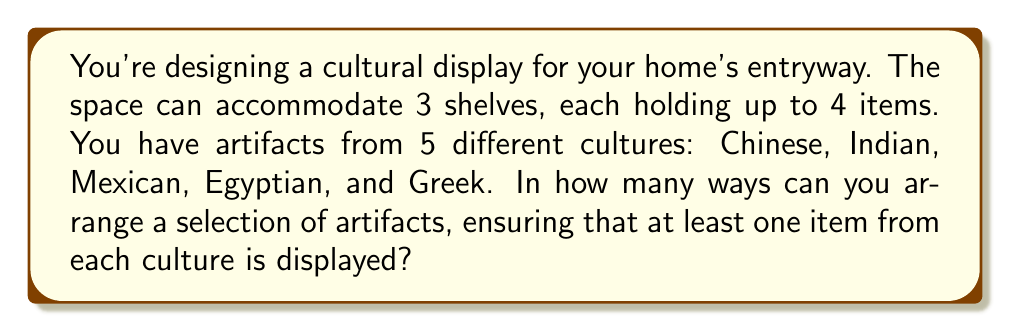Can you answer this question? Let's approach this step-by-step:

1) First, we need to ensure that at least one item from each culture is displayed. This means we must choose 5 items, one from each culture, to start with.

2) After placing these 5 items, we have $3 \times 4 - 5 = 7$ spaces left to fill.

3) For these remaining 7 spaces, we can choose any items from any culture. This is equivalent to choosing with replacement from 5 options (cultures) for 7 positions.

4) The number of ways to do this is $5^7$, as for each of the 7 positions, we have 5 choices.

5) However, we're not done yet. We need to consider the arrangement of all these items on the shelves.

6) The total number of items we're arranging is $5 + 7 = 12$.

7) This is a permutation problem. The number of ways to arrange 12 items is $12!$.

8) Therefore, the total number of possible arrangements is:

   $$ 5^7 \times 12! $$

9) Calculating this:
   $5^7 = 78,125$
   $12! = 479,001,600$

   $78,125 \times 479,001,600 = 37,421,875,000,000$
Answer: $37,421,875,000,000$ 